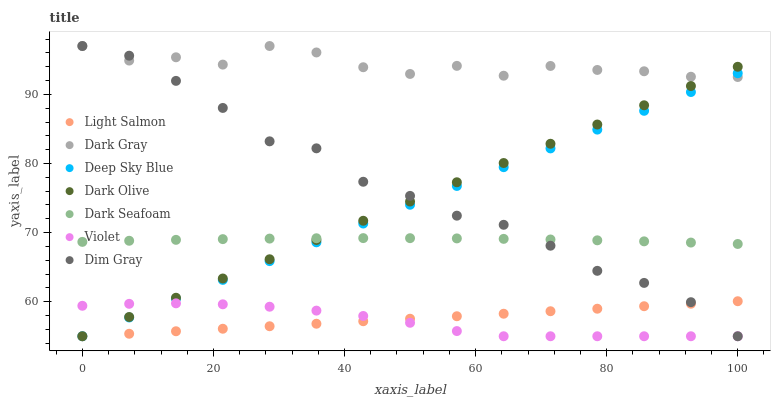Does Violet have the minimum area under the curve?
Answer yes or no. Yes. Does Dark Gray have the maximum area under the curve?
Answer yes or no. Yes. Does Dim Gray have the minimum area under the curve?
Answer yes or no. No. Does Dim Gray have the maximum area under the curve?
Answer yes or no. No. Is Light Salmon the smoothest?
Answer yes or no. Yes. Is Dark Gray the roughest?
Answer yes or no. Yes. Is Dim Gray the smoothest?
Answer yes or no. No. Is Dim Gray the roughest?
Answer yes or no. No. Does Light Salmon have the lowest value?
Answer yes or no. Yes. Does Dark Gray have the lowest value?
Answer yes or no. No. Does Dark Gray have the highest value?
Answer yes or no. Yes. Does Dark Olive have the highest value?
Answer yes or no. No. Is Violet less than Dark Gray?
Answer yes or no. Yes. Is Dark Seafoam greater than Light Salmon?
Answer yes or no. Yes. Does Light Salmon intersect Dim Gray?
Answer yes or no. Yes. Is Light Salmon less than Dim Gray?
Answer yes or no. No. Is Light Salmon greater than Dim Gray?
Answer yes or no. No. Does Violet intersect Dark Gray?
Answer yes or no. No. 